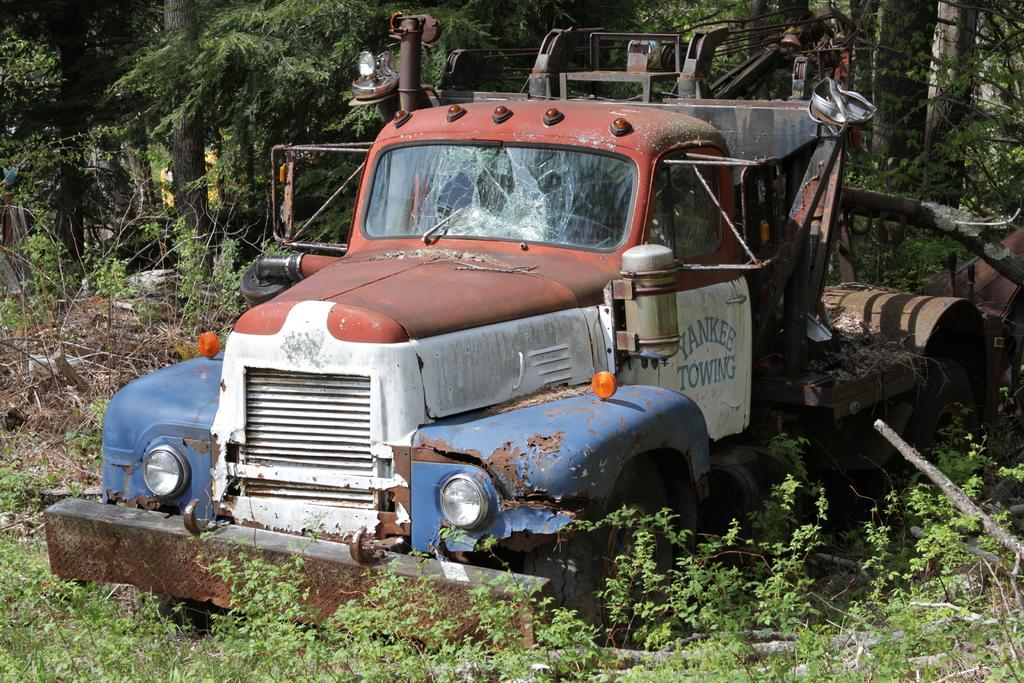What is the main subject of the image? There is a vehicle in the image. Where is the vehicle located? The vehicle is on the ground. What can be seen in the background of the image? There are trees in the background of the image. What type of caption is written on the vehicle in the image? There is no caption visible on the vehicle in the image. Is there a lawyer present in the image? There is no mention of a lawyer or any person in the image; it only features a vehicle on the ground with trees in the background. 